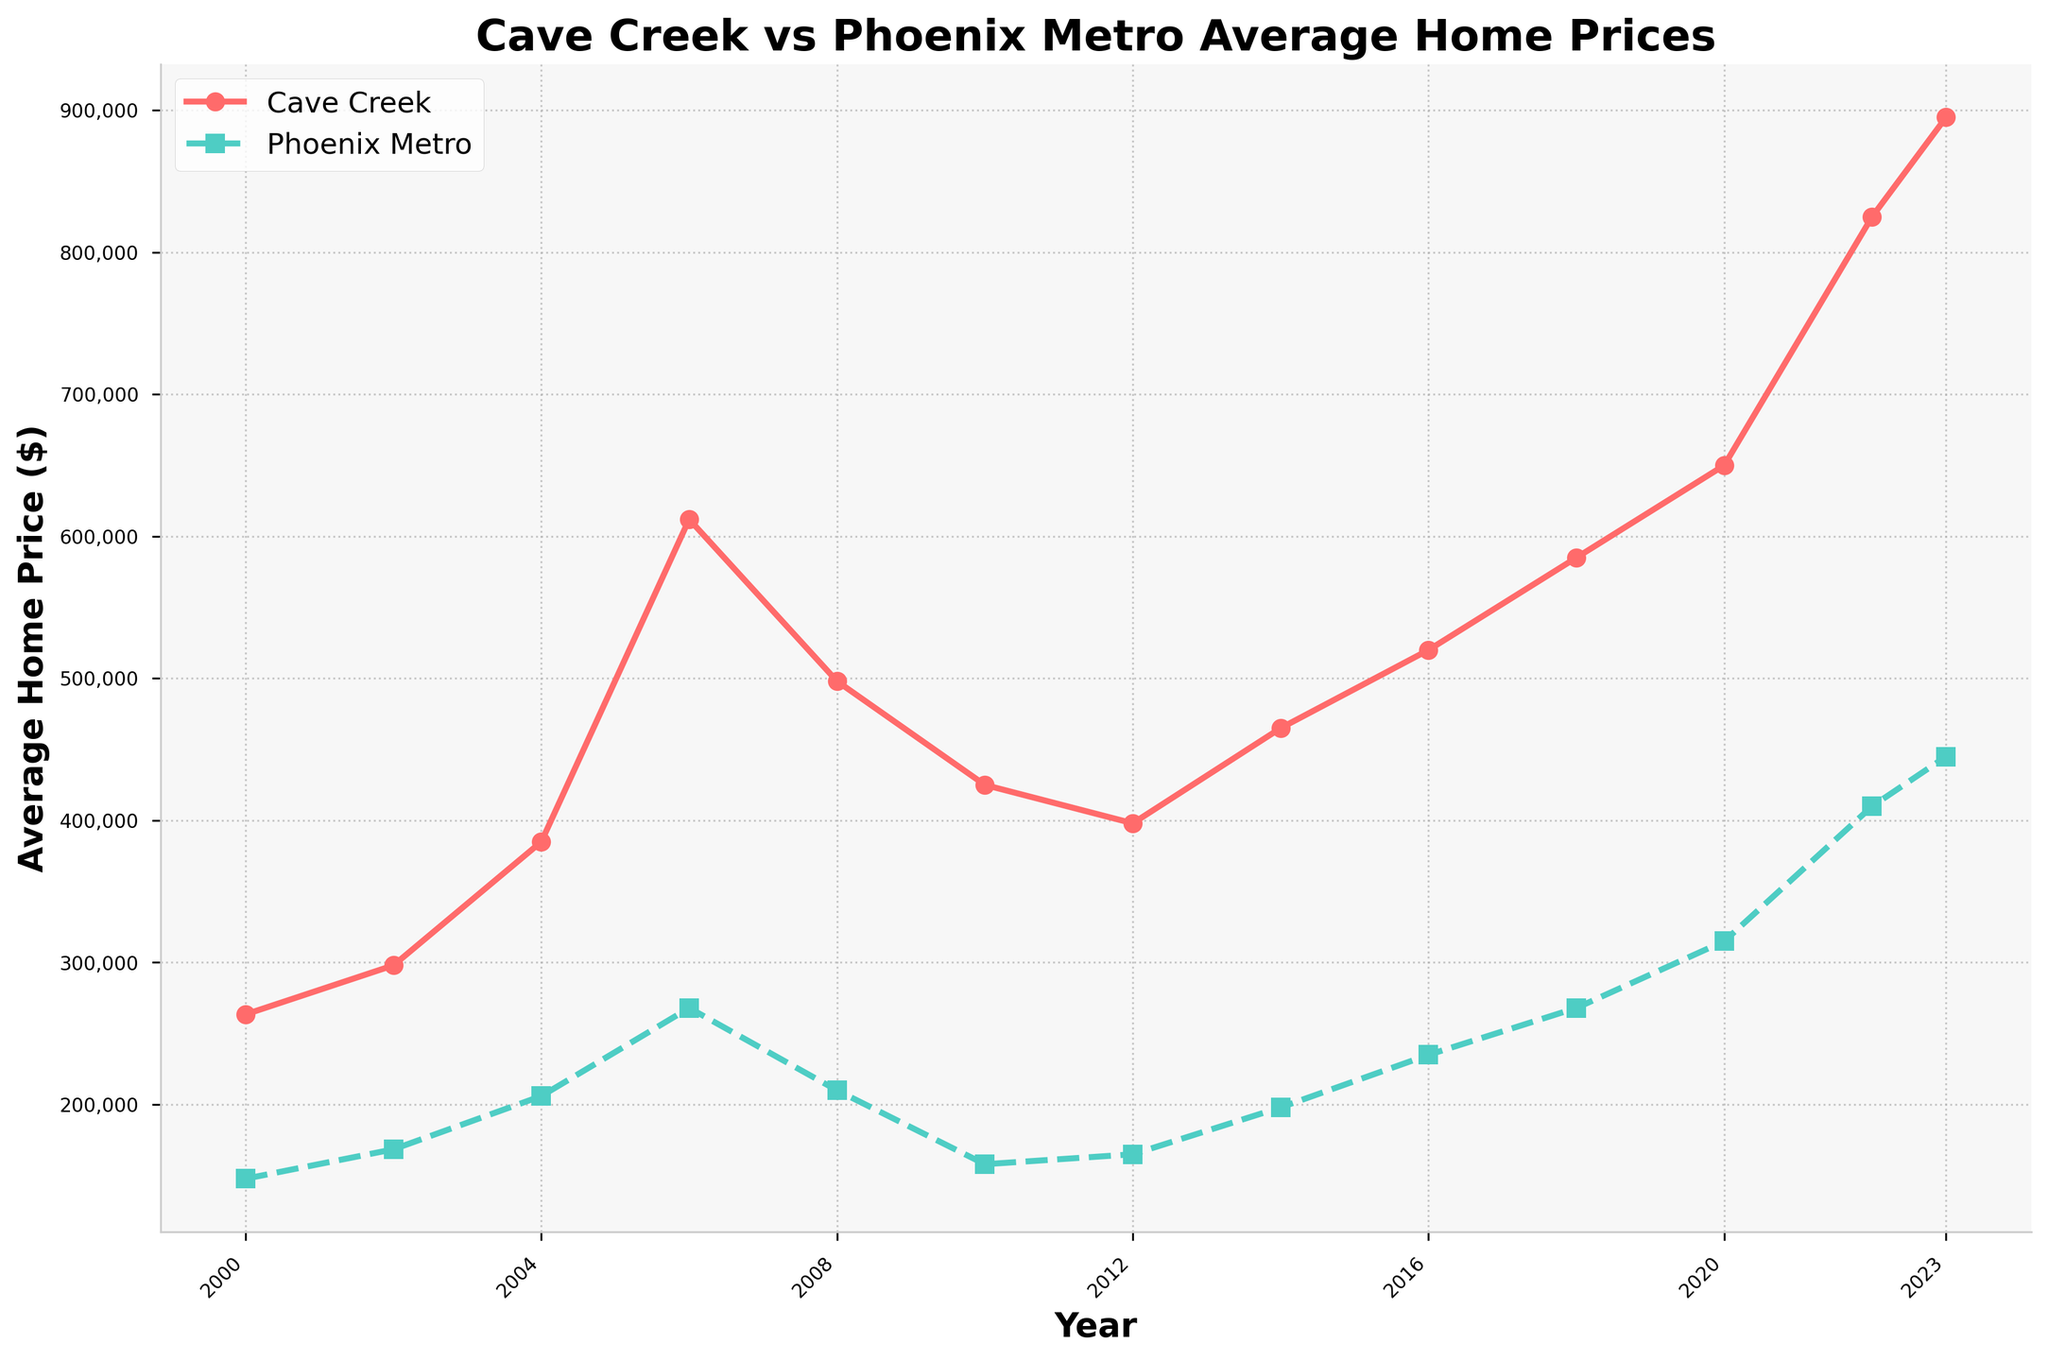What is the highest average home price in Cave Creek? The highest average home price in Cave Creek can be observed at the rightmost point of the Cave Creek line, which occurs in 2023.
Answer: $895,000 What was the trend in average home prices for Phoenix Metro from 2008 to 2012? To identify the trend, compare the values for Phoenix Metro from 2008 ($210,000), 2010 ($158,000), and 2012 ($165,000). The prices show a decline from 2008 to 2010, followed by a slight increase from 2010 to 2012.
Answer: It dropped then slightly rose In which year did Cave Creek have an average home price greater than twice the Phoenix Metro's average home price? For each year, calculate whether the figure for Cave Creek is greater than twice the respective figure for Phoenix Metro. In 2006, Cave Creek had $612,000 compared to Phoenix with $268,000 (2 * $268,000 = $536,000).
Answer: 2006 How much did the average home price in Cave Creek increase from 2000 to 2023? Subtract the 2000 price from the 2023 price: $895,000 (2023) - $263,500 (2000).
Answer: $631,500 Between which consecutive years did Cave Creek experience the largest increase in average home price? Calculate the differences between consecutive years for Cave Creek and compare the values. The largest difference is between 2020 ($650,000) and 2022 ($825,000): $825,000 - $650,000 = $175,000.
Answer: 2020 to 2022 Which location had a higher average home price in 2010, and by how much? Compare the 2010 prices: Cave Creek had $425,000 and Phoenix Metro had $158,000. Subtract the lower from the higher: $425,000 - $158,000.
Answer: Cave Creek by $267,000 During which year did both Cave Creek and Phoenix Metro experience a drop in average home prices? Identify years where both locations' lines decrease. Both dropped in 2008 and 2010.
Answer: 2008 and 2010 When did Phoenix Metro's average home price first exceed $200,000? Check the figures for Phoenix Metro year by year. It first exceeds $200,000 in 2006 where it reached $268,000.
Answer: 2006 What is the general visual trend of average home prices for both Cave Creek and Phoenix Metro since 2010? Observe the lines for both locations from 2010 onwards. Both lines show a generally upward trend with some fluctuations.
Answer: Upward trend By how much did the average home price in Cave Creek differ from that in Phoenix Metro in 2023? Subtract the Phoenix Metro price in 2023 ($445,000) from the Cave Creek price in 2023 ($895,000).
Answer: $450,000 